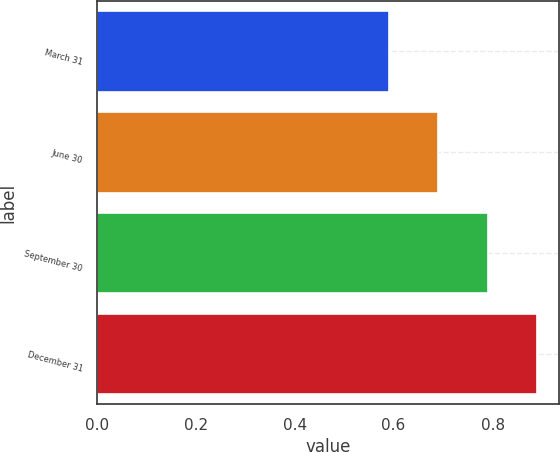Convert chart. <chart><loc_0><loc_0><loc_500><loc_500><bar_chart><fcel>March 31<fcel>June 30<fcel>September 30<fcel>December 31<nl><fcel>0.59<fcel>0.69<fcel>0.79<fcel>0.89<nl></chart> 